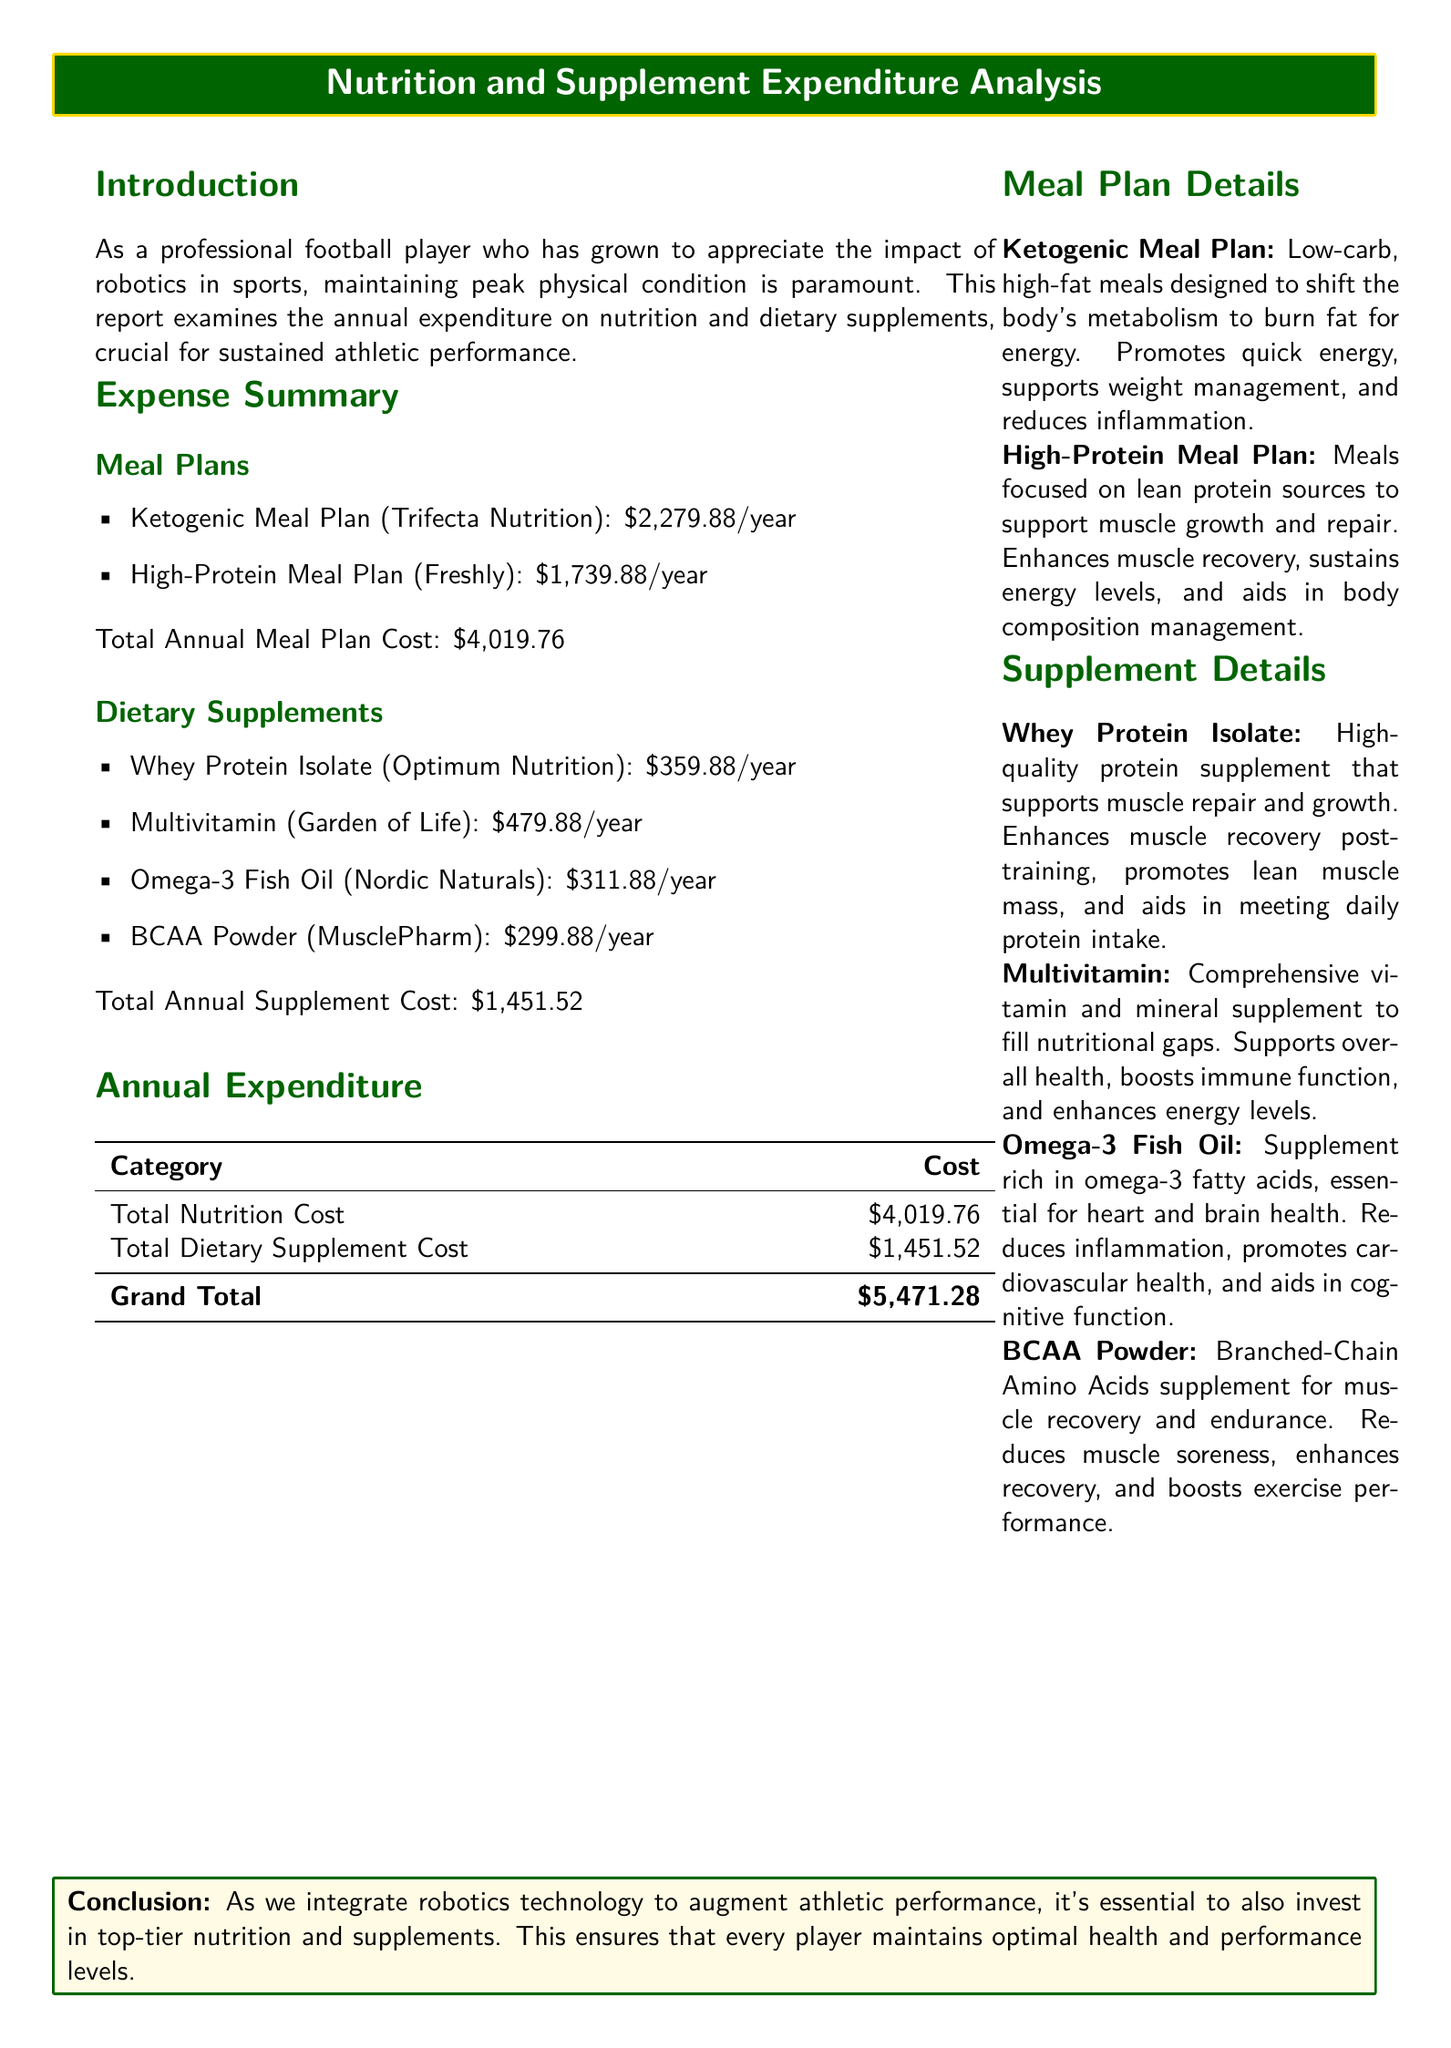What is the total annual meal plan cost? The total annual meal plan cost is the sum of the Ketogenic and High-Protein meal plan costs, which is $2,279.88 + $1,739.88 = $4,019.76.
Answer: $4,019.76 What is the cost of Whey Protein Isolate? The cost of Whey Protein Isolate is listed in the Dietary Supplements section of the document.
Answer: $359.88 What is the total dietary supplement cost? The total dietary supplement cost is the sum of all supplement costs, which is $359.88 + $479.88 + $311.88 + $299.88 = $1,451.52.
Answer: $1,451.52 What is the grand total expenditure? The grand total expenditure is the sum of the total nutrition cost and total dietary supplement cost, which is $4,019.76 + $1,451.52 = $5,471.28.
Answer: $5,471.28 What dietary supplement supports muscle recovery? The document lists specific supplements that enhance muscle recovery, such as Whey Protein Isolate and BCAA Powder.
Answer: Whey Protein Isolate What is one benefit of the Multivitamin? The report states that the Multivitamin supports overall health and boosts immune function.
Answer: Boosts immune function What is the main focus of the High-Protein Meal Plan? The main focus of the High-Protein Meal Plan is on lean protein sources, which aid in muscle growth and repair.
Answer: Lean protein sources What type of meal plan is designed to promote quick energy? The Ketogenic Meal Plan is designed to promote quick energy by shifting the body's metabolism.
Answer: Ketogenic Meal Plan What conclusion is drawn about nutrition and supplements? The conclusion emphasizes the integration of nutrition and supplements with robotics technology to ensure player performance.
Answer: Invest in top-tier nutrition and supplements 